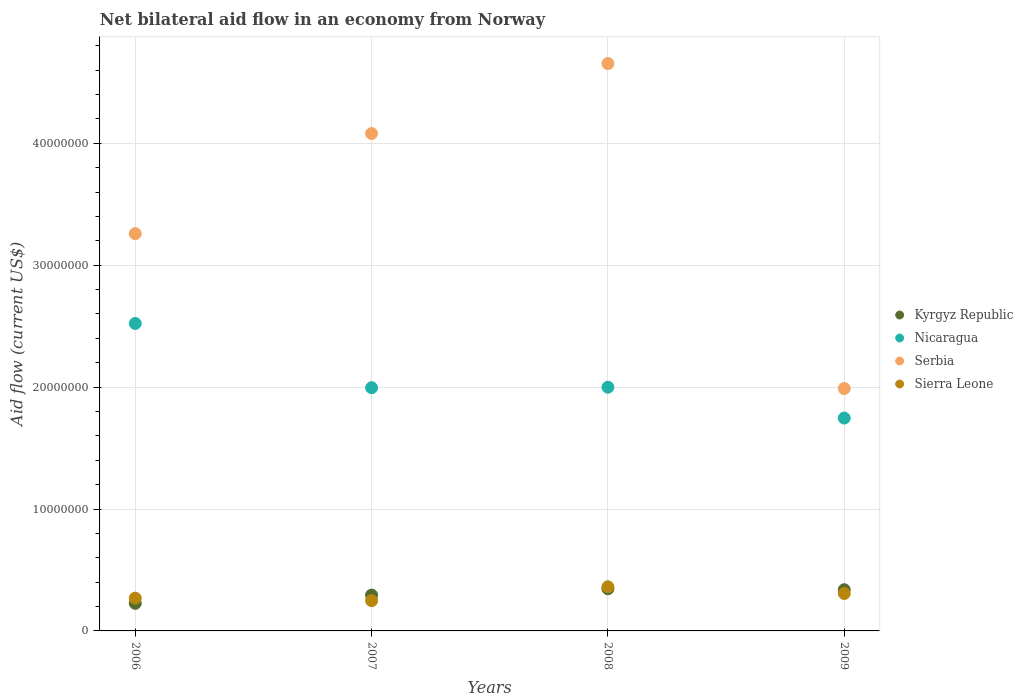How many different coloured dotlines are there?
Your answer should be compact. 4. Is the number of dotlines equal to the number of legend labels?
Offer a terse response. Yes. What is the net bilateral aid flow in Sierra Leone in 2009?
Offer a terse response. 3.07e+06. Across all years, what is the maximum net bilateral aid flow in Nicaragua?
Give a very brief answer. 2.52e+07. Across all years, what is the minimum net bilateral aid flow in Nicaragua?
Provide a short and direct response. 1.75e+07. In which year was the net bilateral aid flow in Nicaragua maximum?
Provide a succinct answer. 2006. What is the total net bilateral aid flow in Serbia in the graph?
Provide a short and direct response. 1.40e+08. What is the difference between the net bilateral aid flow in Kyrgyz Republic in 2007 and that in 2008?
Your response must be concise. -5.20e+05. What is the difference between the net bilateral aid flow in Sierra Leone in 2009 and the net bilateral aid flow in Serbia in 2007?
Your response must be concise. -3.77e+07. What is the average net bilateral aid flow in Sierra Leone per year?
Keep it short and to the point. 2.96e+06. In the year 2009, what is the difference between the net bilateral aid flow in Serbia and net bilateral aid flow in Kyrgyz Republic?
Offer a terse response. 1.65e+07. In how many years, is the net bilateral aid flow in Nicaragua greater than 2000000 US$?
Make the answer very short. 4. What is the ratio of the net bilateral aid flow in Sierra Leone in 2008 to that in 2009?
Provide a short and direct response. 1.18. Is the net bilateral aid flow in Serbia in 2007 less than that in 2009?
Ensure brevity in your answer.  No. What is the difference between the highest and the lowest net bilateral aid flow in Kyrgyz Republic?
Offer a very short reply. 1.20e+06. Is the net bilateral aid flow in Kyrgyz Republic strictly greater than the net bilateral aid flow in Sierra Leone over the years?
Your response must be concise. No. Is the net bilateral aid flow in Kyrgyz Republic strictly less than the net bilateral aid flow in Sierra Leone over the years?
Keep it short and to the point. No. How many years are there in the graph?
Your response must be concise. 4. Are the values on the major ticks of Y-axis written in scientific E-notation?
Your response must be concise. No. Does the graph contain any zero values?
Give a very brief answer. No. Where does the legend appear in the graph?
Your answer should be compact. Center right. How many legend labels are there?
Give a very brief answer. 4. What is the title of the graph?
Give a very brief answer. Net bilateral aid flow in an economy from Norway. Does "Brunei Darussalam" appear as one of the legend labels in the graph?
Your answer should be very brief. No. What is the Aid flow (current US$) of Kyrgyz Republic in 2006?
Ensure brevity in your answer.  2.26e+06. What is the Aid flow (current US$) in Nicaragua in 2006?
Keep it short and to the point. 2.52e+07. What is the Aid flow (current US$) of Serbia in 2006?
Your answer should be compact. 3.26e+07. What is the Aid flow (current US$) in Sierra Leone in 2006?
Keep it short and to the point. 2.69e+06. What is the Aid flow (current US$) of Kyrgyz Republic in 2007?
Ensure brevity in your answer.  2.94e+06. What is the Aid flow (current US$) of Nicaragua in 2007?
Make the answer very short. 2.00e+07. What is the Aid flow (current US$) in Serbia in 2007?
Your answer should be compact. 4.08e+07. What is the Aid flow (current US$) of Sierra Leone in 2007?
Make the answer very short. 2.48e+06. What is the Aid flow (current US$) in Kyrgyz Republic in 2008?
Keep it short and to the point. 3.46e+06. What is the Aid flow (current US$) in Nicaragua in 2008?
Provide a short and direct response. 2.00e+07. What is the Aid flow (current US$) of Serbia in 2008?
Offer a very short reply. 4.65e+07. What is the Aid flow (current US$) in Sierra Leone in 2008?
Offer a very short reply. 3.62e+06. What is the Aid flow (current US$) of Kyrgyz Republic in 2009?
Ensure brevity in your answer.  3.38e+06. What is the Aid flow (current US$) in Nicaragua in 2009?
Give a very brief answer. 1.75e+07. What is the Aid flow (current US$) of Serbia in 2009?
Offer a terse response. 1.99e+07. What is the Aid flow (current US$) in Sierra Leone in 2009?
Make the answer very short. 3.07e+06. Across all years, what is the maximum Aid flow (current US$) of Kyrgyz Republic?
Ensure brevity in your answer.  3.46e+06. Across all years, what is the maximum Aid flow (current US$) of Nicaragua?
Offer a very short reply. 2.52e+07. Across all years, what is the maximum Aid flow (current US$) of Serbia?
Give a very brief answer. 4.65e+07. Across all years, what is the maximum Aid flow (current US$) of Sierra Leone?
Your answer should be very brief. 3.62e+06. Across all years, what is the minimum Aid flow (current US$) of Kyrgyz Republic?
Provide a short and direct response. 2.26e+06. Across all years, what is the minimum Aid flow (current US$) in Nicaragua?
Give a very brief answer. 1.75e+07. Across all years, what is the minimum Aid flow (current US$) in Serbia?
Your response must be concise. 1.99e+07. Across all years, what is the minimum Aid flow (current US$) of Sierra Leone?
Make the answer very short. 2.48e+06. What is the total Aid flow (current US$) in Kyrgyz Republic in the graph?
Give a very brief answer. 1.20e+07. What is the total Aid flow (current US$) of Nicaragua in the graph?
Offer a terse response. 8.26e+07. What is the total Aid flow (current US$) in Serbia in the graph?
Offer a very short reply. 1.40e+08. What is the total Aid flow (current US$) in Sierra Leone in the graph?
Ensure brevity in your answer.  1.19e+07. What is the difference between the Aid flow (current US$) of Kyrgyz Republic in 2006 and that in 2007?
Offer a terse response. -6.80e+05. What is the difference between the Aid flow (current US$) of Nicaragua in 2006 and that in 2007?
Offer a terse response. 5.27e+06. What is the difference between the Aid flow (current US$) in Serbia in 2006 and that in 2007?
Offer a very short reply. -8.21e+06. What is the difference between the Aid flow (current US$) in Kyrgyz Republic in 2006 and that in 2008?
Provide a succinct answer. -1.20e+06. What is the difference between the Aid flow (current US$) in Nicaragua in 2006 and that in 2008?
Ensure brevity in your answer.  5.23e+06. What is the difference between the Aid flow (current US$) of Serbia in 2006 and that in 2008?
Your answer should be compact. -1.40e+07. What is the difference between the Aid flow (current US$) in Sierra Leone in 2006 and that in 2008?
Provide a short and direct response. -9.30e+05. What is the difference between the Aid flow (current US$) in Kyrgyz Republic in 2006 and that in 2009?
Make the answer very short. -1.12e+06. What is the difference between the Aid flow (current US$) in Nicaragua in 2006 and that in 2009?
Offer a terse response. 7.76e+06. What is the difference between the Aid flow (current US$) of Serbia in 2006 and that in 2009?
Your answer should be compact. 1.27e+07. What is the difference between the Aid flow (current US$) in Sierra Leone in 2006 and that in 2009?
Your response must be concise. -3.80e+05. What is the difference between the Aid flow (current US$) of Kyrgyz Republic in 2007 and that in 2008?
Provide a succinct answer. -5.20e+05. What is the difference between the Aid flow (current US$) in Nicaragua in 2007 and that in 2008?
Keep it short and to the point. -4.00e+04. What is the difference between the Aid flow (current US$) of Serbia in 2007 and that in 2008?
Your response must be concise. -5.74e+06. What is the difference between the Aid flow (current US$) in Sierra Leone in 2007 and that in 2008?
Give a very brief answer. -1.14e+06. What is the difference between the Aid flow (current US$) in Kyrgyz Republic in 2007 and that in 2009?
Your response must be concise. -4.40e+05. What is the difference between the Aid flow (current US$) of Nicaragua in 2007 and that in 2009?
Your answer should be compact. 2.49e+06. What is the difference between the Aid flow (current US$) of Serbia in 2007 and that in 2009?
Give a very brief answer. 2.09e+07. What is the difference between the Aid flow (current US$) of Sierra Leone in 2007 and that in 2009?
Ensure brevity in your answer.  -5.90e+05. What is the difference between the Aid flow (current US$) in Kyrgyz Republic in 2008 and that in 2009?
Keep it short and to the point. 8.00e+04. What is the difference between the Aid flow (current US$) in Nicaragua in 2008 and that in 2009?
Keep it short and to the point. 2.53e+06. What is the difference between the Aid flow (current US$) of Serbia in 2008 and that in 2009?
Your response must be concise. 2.67e+07. What is the difference between the Aid flow (current US$) of Sierra Leone in 2008 and that in 2009?
Your answer should be compact. 5.50e+05. What is the difference between the Aid flow (current US$) in Kyrgyz Republic in 2006 and the Aid flow (current US$) in Nicaragua in 2007?
Provide a short and direct response. -1.77e+07. What is the difference between the Aid flow (current US$) of Kyrgyz Republic in 2006 and the Aid flow (current US$) of Serbia in 2007?
Your response must be concise. -3.85e+07. What is the difference between the Aid flow (current US$) of Kyrgyz Republic in 2006 and the Aid flow (current US$) of Sierra Leone in 2007?
Give a very brief answer. -2.20e+05. What is the difference between the Aid flow (current US$) of Nicaragua in 2006 and the Aid flow (current US$) of Serbia in 2007?
Offer a terse response. -1.56e+07. What is the difference between the Aid flow (current US$) in Nicaragua in 2006 and the Aid flow (current US$) in Sierra Leone in 2007?
Keep it short and to the point. 2.27e+07. What is the difference between the Aid flow (current US$) of Serbia in 2006 and the Aid flow (current US$) of Sierra Leone in 2007?
Ensure brevity in your answer.  3.01e+07. What is the difference between the Aid flow (current US$) of Kyrgyz Republic in 2006 and the Aid flow (current US$) of Nicaragua in 2008?
Your answer should be very brief. -1.77e+07. What is the difference between the Aid flow (current US$) of Kyrgyz Republic in 2006 and the Aid flow (current US$) of Serbia in 2008?
Ensure brevity in your answer.  -4.43e+07. What is the difference between the Aid flow (current US$) in Kyrgyz Republic in 2006 and the Aid flow (current US$) in Sierra Leone in 2008?
Ensure brevity in your answer.  -1.36e+06. What is the difference between the Aid flow (current US$) in Nicaragua in 2006 and the Aid flow (current US$) in Serbia in 2008?
Provide a succinct answer. -2.13e+07. What is the difference between the Aid flow (current US$) in Nicaragua in 2006 and the Aid flow (current US$) in Sierra Leone in 2008?
Keep it short and to the point. 2.16e+07. What is the difference between the Aid flow (current US$) in Serbia in 2006 and the Aid flow (current US$) in Sierra Leone in 2008?
Your answer should be very brief. 2.90e+07. What is the difference between the Aid flow (current US$) in Kyrgyz Republic in 2006 and the Aid flow (current US$) in Nicaragua in 2009?
Your answer should be compact. -1.52e+07. What is the difference between the Aid flow (current US$) in Kyrgyz Republic in 2006 and the Aid flow (current US$) in Serbia in 2009?
Your response must be concise. -1.76e+07. What is the difference between the Aid flow (current US$) in Kyrgyz Republic in 2006 and the Aid flow (current US$) in Sierra Leone in 2009?
Make the answer very short. -8.10e+05. What is the difference between the Aid flow (current US$) of Nicaragua in 2006 and the Aid flow (current US$) of Serbia in 2009?
Your answer should be very brief. 5.34e+06. What is the difference between the Aid flow (current US$) of Nicaragua in 2006 and the Aid flow (current US$) of Sierra Leone in 2009?
Keep it short and to the point. 2.22e+07. What is the difference between the Aid flow (current US$) in Serbia in 2006 and the Aid flow (current US$) in Sierra Leone in 2009?
Your answer should be compact. 2.95e+07. What is the difference between the Aid flow (current US$) of Kyrgyz Republic in 2007 and the Aid flow (current US$) of Nicaragua in 2008?
Offer a very short reply. -1.70e+07. What is the difference between the Aid flow (current US$) of Kyrgyz Republic in 2007 and the Aid flow (current US$) of Serbia in 2008?
Your answer should be compact. -4.36e+07. What is the difference between the Aid flow (current US$) of Kyrgyz Republic in 2007 and the Aid flow (current US$) of Sierra Leone in 2008?
Offer a terse response. -6.80e+05. What is the difference between the Aid flow (current US$) in Nicaragua in 2007 and the Aid flow (current US$) in Serbia in 2008?
Your response must be concise. -2.66e+07. What is the difference between the Aid flow (current US$) in Nicaragua in 2007 and the Aid flow (current US$) in Sierra Leone in 2008?
Give a very brief answer. 1.63e+07. What is the difference between the Aid flow (current US$) of Serbia in 2007 and the Aid flow (current US$) of Sierra Leone in 2008?
Your answer should be very brief. 3.72e+07. What is the difference between the Aid flow (current US$) in Kyrgyz Republic in 2007 and the Aid flow (current US$) in Nicaragua in 2009?
Your answer should be compact. -1.45e+07. What is the difference between the Aid flow (current US$) in Kyrgyz Republic in 2007 and the Aid flow (current US$) in Serbia in 2009?
Give a very brief answer. -1.69e+07. What is the difference between the Aid flow (current US$) in Kyrgyz Republic in 2007 and the Aid flow (current US$) in Sierra Leone in 2009?
Give a very brief answer. -1.30e+05. What is the difference between the Aid flow (current US$) in Nicaragua in 2007 and the Aid flow (current US$) in Sierra Leone in 2009?
Your response must be concise. 1.69e+07. What is the difference between the Aid flow (current US$) of Serbia in 2007 and the Aid flow (current US$) of Sierra Leone in 2009?
Offer a terse response. 3.77e+07. What is the difference between the Aid flow (current US$) of Kyrgyz Republic in 2008 and the Aid flow (current US$) of Nicaragua in 2009?
Your response must be concise. -1.40e+07. What is the difference between the Aid flow (current US$) of Kyrgyz Republic in 2008 and the Aid flow (current US$) of Serbia in 2009?
Your answer should be compact. -1.64e+07. What is the difference between the Aid flow (current US$) in Nicaragua in 2008 and the Aid flow (current US$) in Sierra Leone in 2009?
Offer a terse response. 1.69e+07. What is the difference between the Aid flow (current US$) in Serbia in 2008 and the Aid flow (current US$) in Sierra Leone in 2009?
Offer a terse response. 4.35e+07. What is the average Aid flow (current US$) of Kyrgyz Republic per year?
Offer a terse response. 3.01e+06. What is the average Aid flow (current US$) of Nicaragua per year?
Give a very brief answer. 2.07e+07. What is the average Aid flow (current US$) in Serbia per year?
Make the answer very short. 3.50e+07. What is the average Aid flow (current US$) in Sierra Leone per year?
Provide a short and direct response. 2.96e+06. In the year 2006, what is the difference between the Aid flow (current US$) of Kyrgyz Republic and Aid flow (current US$) of Nicaragua?
Give a very brief answer. -2.30e+07. In the year 2006, what is the difference between the Aid flow (current US$) of Kyrgyz Republic and Aid flow (current US$) of Serbia?
Offer a very short reply. -3.03e+07. In the year 2006, what is the difference between the Aid flow (current US$) in Kyrgyz Republic and Aid flow (current US$) in Sierra Leone?
Provide a succinct answer. -4.30e+05. In the year 2006, what is the difference between the Aid flow (current US$) of Nicaragua and Aid flow (current US$) of Serbia?
Your response must be concise. -7.37e+06. In the year 2006, what is the difference between the Aid flow (current US$) in Nicaragua and Aid flow (current US$) in Sierra Leone?
Your response must be concise. 2.25e+07. In the year 2006, what is the difference between the Aid flow (current US$) of Serbia and Aid flow (current US$) of Sierra Leone?
Ensure brevity in your answer.  2.99e+07. In the year 2007, what is the difference between the Aid flow (current US$) in Kyrgyz Republic and Aid flow (current US$) in Nicaragua?
Ensure brevity in your answer.  -1.70e+07. In the year 2007, what is the difference between the Aid flow (current US$) in Kyrgyz Republic and Aid flow (current US$) in Serbia?
Provide a succinct answer. -3.79e+07. In the year 2007, what is the difference between the Aid flow (current US$) of Nicaragua and Aid flow (current US$) of Serbia?
Offer a terse response. -2.08e+07. In the year 2007, what is the difference between the Aid flow (current US$) in Nicaragua and Aid flow (current US$) in Sierra Leone?
Keep it short and to the point. 1.75e+07. In the year 2007, what is the difference between the Aid flow (current US$) of Serbia and Aid flow (current US$) of Sierra Leone?
Make the answer very short. 3.83e+07. In the year 2008, what is the difference between the Aid flow (current US$) in Kyrgyz Republic and Aid flow (current US$) in Nicaragua?
Your answer should be compact. -1.65e+07. In the year 2008, what is the difference between the Aid flow (current US$) in Kyrgyz Republic and Aid flow (current US$) in Serbia?
Provide a succinct answer. -4.31e+07. In the year 2008, what is the difference between the Aid flow (current US$) of Nicaragua and Aid flow (current US$) of Serbia?
Provide a succinct answer. -2.66e+07. In the year 2008, what is the difference between the Aid flow (current US$) of Nicaragua and Aid flow (current US$) of Sierra Leone?
Ensure brevity in your answer.  1.64e+07. In the year 2008, what is the difference between the Aid flow (current US$) of Serbia and Aid flow (current US$) of Sierra Leone?
Keep it short and to the point. 4.29e+07. In the year 2009, what is the difference between the Aid flow (current US$) of Kyrgyz Republic and Aid flow (current US$) of Nicaragua?
Provide a succinct answer. -1.41e+07. In the year 2009, what is the difference between the Aid flow (current US$) of Kyrgyz Republic and Aid flow (current US$) of Serbia?
Offer a terse response. -1.65e+07. In the year 2009, what is the difference between the Aid flow (current US$) of Nicaragua and Aid flow (current US$) of Serbia?
Your answer should be very brief. -2.42e+06. In the year 2009, what is the difference between the Aid flow (current US$) of Nicaragua and Aid flow (current US$) of Sierra Leone?
Provide a short and direct response. 1.44e+07. In the year 2009, what is the difference between the Aid flow (current US$) of Serbia and Aid flow (current US$) of Sierra Leone?
Your answer should be compact. 1.68e+07. What is the ratio of the Aid flow (current US$) in Kyrgyz Republic in 2006 to that in 2007?
Offer a very short reply. 0.77. What is the ratio of the Aid flow (current US$) in Nicaragua in 2006 to that in 2007?
Your response must be concise. 1.26. What is the ratio of the Aid flow (current US$) in Serbia in 2006 to that in 2007?
Provide a short and direct response. 0.8. What is the ratio of the Aid flow (current US$) in Sierra Leone in 2006 to that in 2007?
Provide a short and direct response. 1.08. What is the ratio of the Aid flow (current US$) of Kyrgyz Republic in 2006 to that in 2008?
Provide a short and direct response. 0.65. What is the ratio of the Aid flow (current US$) in Nicaragua in 2006 to that in 2008?
Provide a short and direct response. 1.26. What is the ratio of the Aid flow (current US$) in Serbia in 2006 to that in 2008?
Ensure brevity in your answer.  0.7. What is the ratio of the Aid flow (current US$) in Sierra Leone in 2006 to that in 2008?
Your answer should be very brief. 0.74. What is the ratio of the Aid flow (current US$) in Kyrgyz Republic in 2006 to that in 2009?
Offer a very short reply. 0.67. What is the ratio of the Aid flow (current US$) in Nicaragua in 2006 to that in 2009?
Offer a very short reply. 1.44. What is the ratio of the Aid flow (current US$) in Serbia in 2006 to that in 2009?
Give a very brief answer. 1.64. What is the ratio of the Aid flow (current US$) in Sierra Leone in 2006 to that in 2009?
Your answer should be compact. 0.88. What is the ratio of the Aid flow (current US$) of Kyrgyz Republic in 2007 to that in 2008?
Your response must be concise. 0.85. What is the ratio of the Aid flow (current US$) of Serbia in 2007 to that in 2008?
Provide a succinct answer. 0.88. What is the ratio of the Aid flow (current US$) of Sierra Leone in 2007 to that in 2008?
Offer a terse response. 0.69. What is the ratio of the Aid flow (current US$) of Kyrgyz Republic in 2007 to that in 2009?
Your answer should be very brief. 0.87. What is the ratio of the Aid flow (current US$) in Nicaragua in 2007 to that in 2009?
Your answer should be very brief. 1.14. What is the ratio of the Aid flow (current US$) in Serbia in 2007 to that in 2009?
Keep it short and to the point. 2.05. What is the ratio of the Aid flow (current US$) in Sierra Leone in 2007 to that in 2009?
Your answer should be very brief. 0.81. What is the ratio of the Aid flow (current US$) of Kyrgyz Republic in 2008 to that in 2009?
Your answer should be very brief. 1.02. What is the ratio of the Aid flow (current US$) in Nicaragua in 2008 to that in 2009?
Offer a very short reply. 1.14. What is the ratio of the Aid flow (current US$) in Serbia in 2008 to that in 2009?
Offer a very short reply. 2.34. What is the ratio of the Aid flow (current US$) of Sierra Leone in 2008 to that in 2009?
Make the answer very short. 1.18. What is the difference between the highest and the second highest Aid flow (current US$) in Nicaragua?
Keep it short and to the point. 5.23e+06. What is the difference between the highest and the second highest Aid flow (current US$) of Serbia?
Keep it short and to the point. 5.74e+06. What is the difference between the highest and the second highest Aid flow (current US$) in Sierra Leone?
Your response must be concise. 5.50e+05. What is the difference between the highest and the lowest Aid flow (current US$) in Kyrgyz Republic?
Ensure brevity in your answer.  1.20e+06. What is the difference between the highest and the lowest Aid flow (current US$) in Nicaragua?
Offer a terse response. 7.76e+06. What is the difference between the highest and the lowest Aid flow (current US$) in Serbia?
Your response must be concise. 2.67e+07. What is the difference between the highest and the lowest Aid flow (current US$) in Sierra Leone?
Offer a terse response. 1.14e+06. 